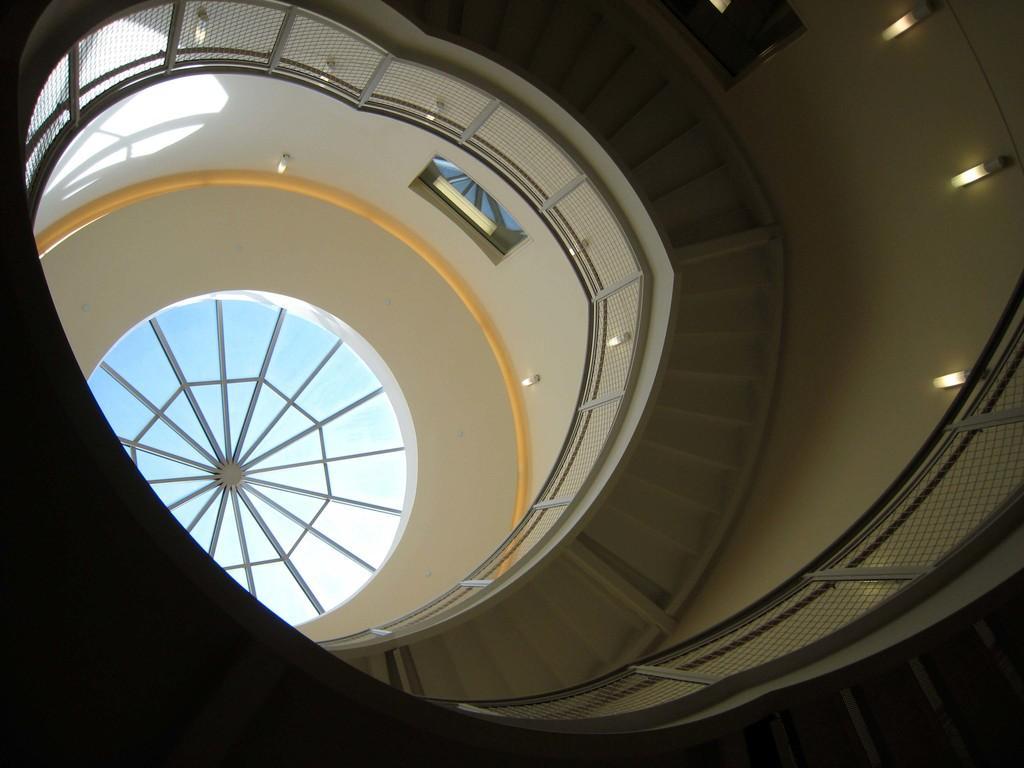What type of structure is present in the image? There is a staircase in the image. What can be seen illuminating the area in the image? There are lights visible in the image. What is located above the structure in the image? There is a roof in the image. What allows natural light to enter the structure in the image? There are windows visible in the image. What company is responsible for the form of the staircase in the image? There is no information about a company or the form of the staircase in the image. 